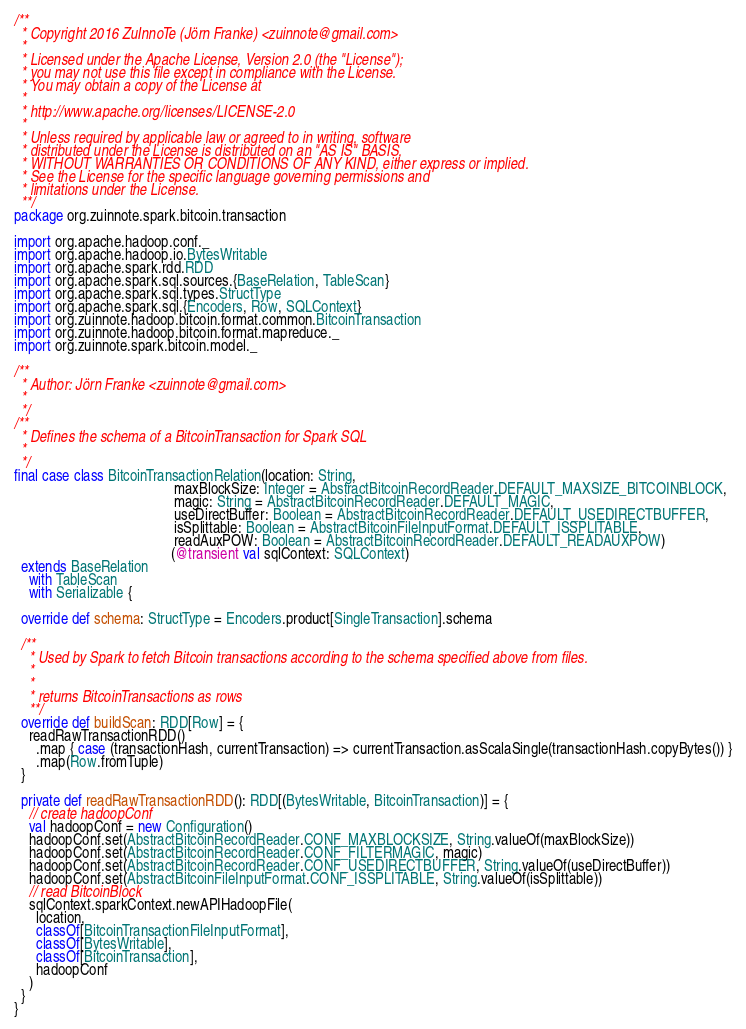Convert code to text. <code><loc_0><loc_0><loc_500><loc_500><_Scala_>/**
  * Copyright 2016 ZuInnoTe (Jörn Franke) <zuinnote@gmail.com>
  *
  * Licensed under the Apache License, Version 2.0 (the "License");
  * you may not use this file except in compliance with the License.
  * You may obtain a copy of the License at
  *
  * http://www.apache.org/licenses/LICENSE-2.0
  *
  * Unless required by applicable law or agreed to in writing, software
  * distributed under the License is distributed on an "AS IS" BASIS,
  * WITHOUT WARRANTIES OR CONDITIONS OF ANY KIND, either express or implied.
  * See the License for the specific language governing permissions and
  * limitations under the License.
  **/
package org.zuinnote.spark.bitcoin.transaction

import org.apache.hadoop.conf._
import org.apache.hadoop.io.BytesWritable
import org.apache.spark.rdd.RDD
import org.apache.spark.sql.sources.{BaseRelation, TableScan}
import org.apache.spark.sql.types.StructType
import org.apache.spark.sql.{Encoders, Row, SQLContext}
import org.zuinnote.hadoop.bitcoin.format.common.BitcoinTransaction
import org.zuinnote.hadoop.bitcoin.format.mapreduce._
import org.zuinnote.spark.bitcoin.model._

/**
  * Author: Jörn Franke <zuinnote@gmail.com>
  *
  */
/**
  * Defines the schema of a BitcoinTransaction for Spark SQL
  *
  */
final case class BitcoinTransactionRelation(location: String,
                                            maxBlockSize: Integer = AbstractBitcoinRecordReader.DEFAULT_MAXSIZE_BITCOINBLOCK,
                                            magic: String = AbstractBitcoinRecordReader.DEFAULT_MAGIC,
                                            useDirectBuffer: Boolean = AbstractBitcoinRecordReader.DEFAULT_USEDIRECTBUFFER,
                                            isSplittable: Boolean = AbstractBitcoinFileInputFormat.DEFAULT_ISSPLITABLE,
                                            readAuxPOW: Boolean = AbstractBitcoinRecordReader.DEFAULT_READAUXPOW)
                                           (@transient val sqlContext: SQLContext)
  extends BaseRelation
    with TableScan
    with Serializable {

  override def schema: StructType = Encoders.product[SingleTransaction].schema

  /**
    * Used by Spark to fetch Bitcoin transactions according to the schema specified above from files.
    *
    *
    * returns BitcoinTransactions as rows
    **/
  override def buildScan: RDD[Row] = {
    readRawTransactionRDD()
      .map { case (transactionHash, currentTransaction) => currentTransaction.asScalaSingle(transactionHash.copyBytes()) }
      .map(Row.fromTuple)
  }

  private def readRawTransactionRDD(): RDD[(BytesWritable, BitcoinTransaction)] = {
    // create hadoopConf
    val hadoopConf = new Configuration()
    hadoopConf.set(AbstractBitcoinRecordReader.CONF_MAXBLOCKSIZE, String.valueOf(maxBlockSize))
    hadoopConf.set(AbstractBitcoinRecordReader.CONF_FILTERMAGIC, magic)
    hadoopConf.set(AbstractBitcoinRecordReader.CONF_USEDIRECTBUFFER, String.valueOf(useDirectBuffer))
    hadoopConf.set(AbstractBitcoinFileInputFormat.CONF_ISSPLITABLE, String.valueOf(isSplittable))
    // read BitcoinBlock
    sqlContext.sparkContext.newAPIHadoopFile(
      location,
      classOf[BitcoinTransactionFileInputFormat],
      classOf[BytesWritable],
      classOf[BitcoinTransaction],
      hadoopConf
    )
  }
}
</code> 